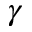Convert formula to latex. <formula><loc_0><loc_0><loc_500><loc_500>\gamma</formula> 